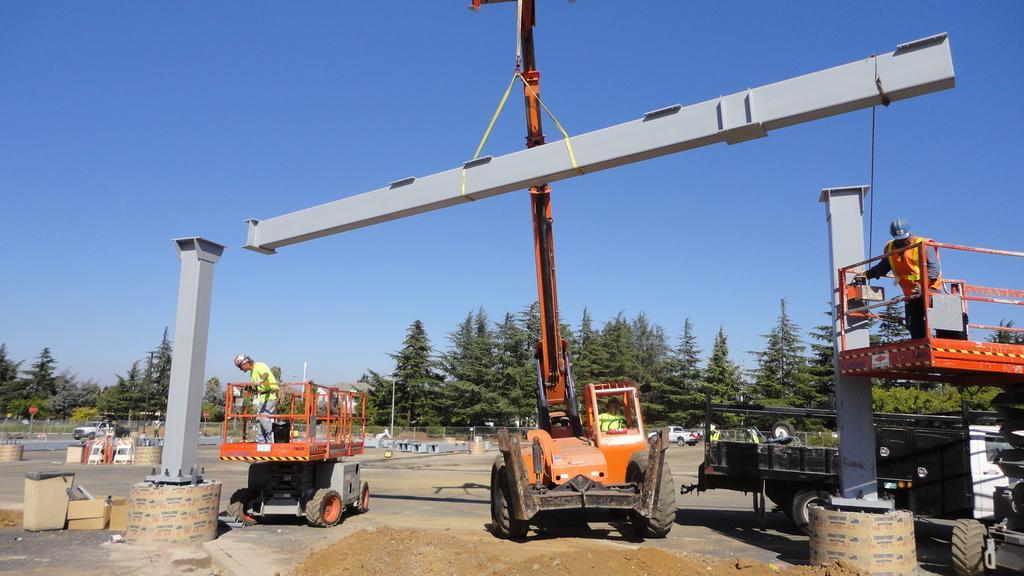Can you describe this image briefly? In this image I can see vehicles, trees, poles and other objects on the ground. In the background I can see the sky. 